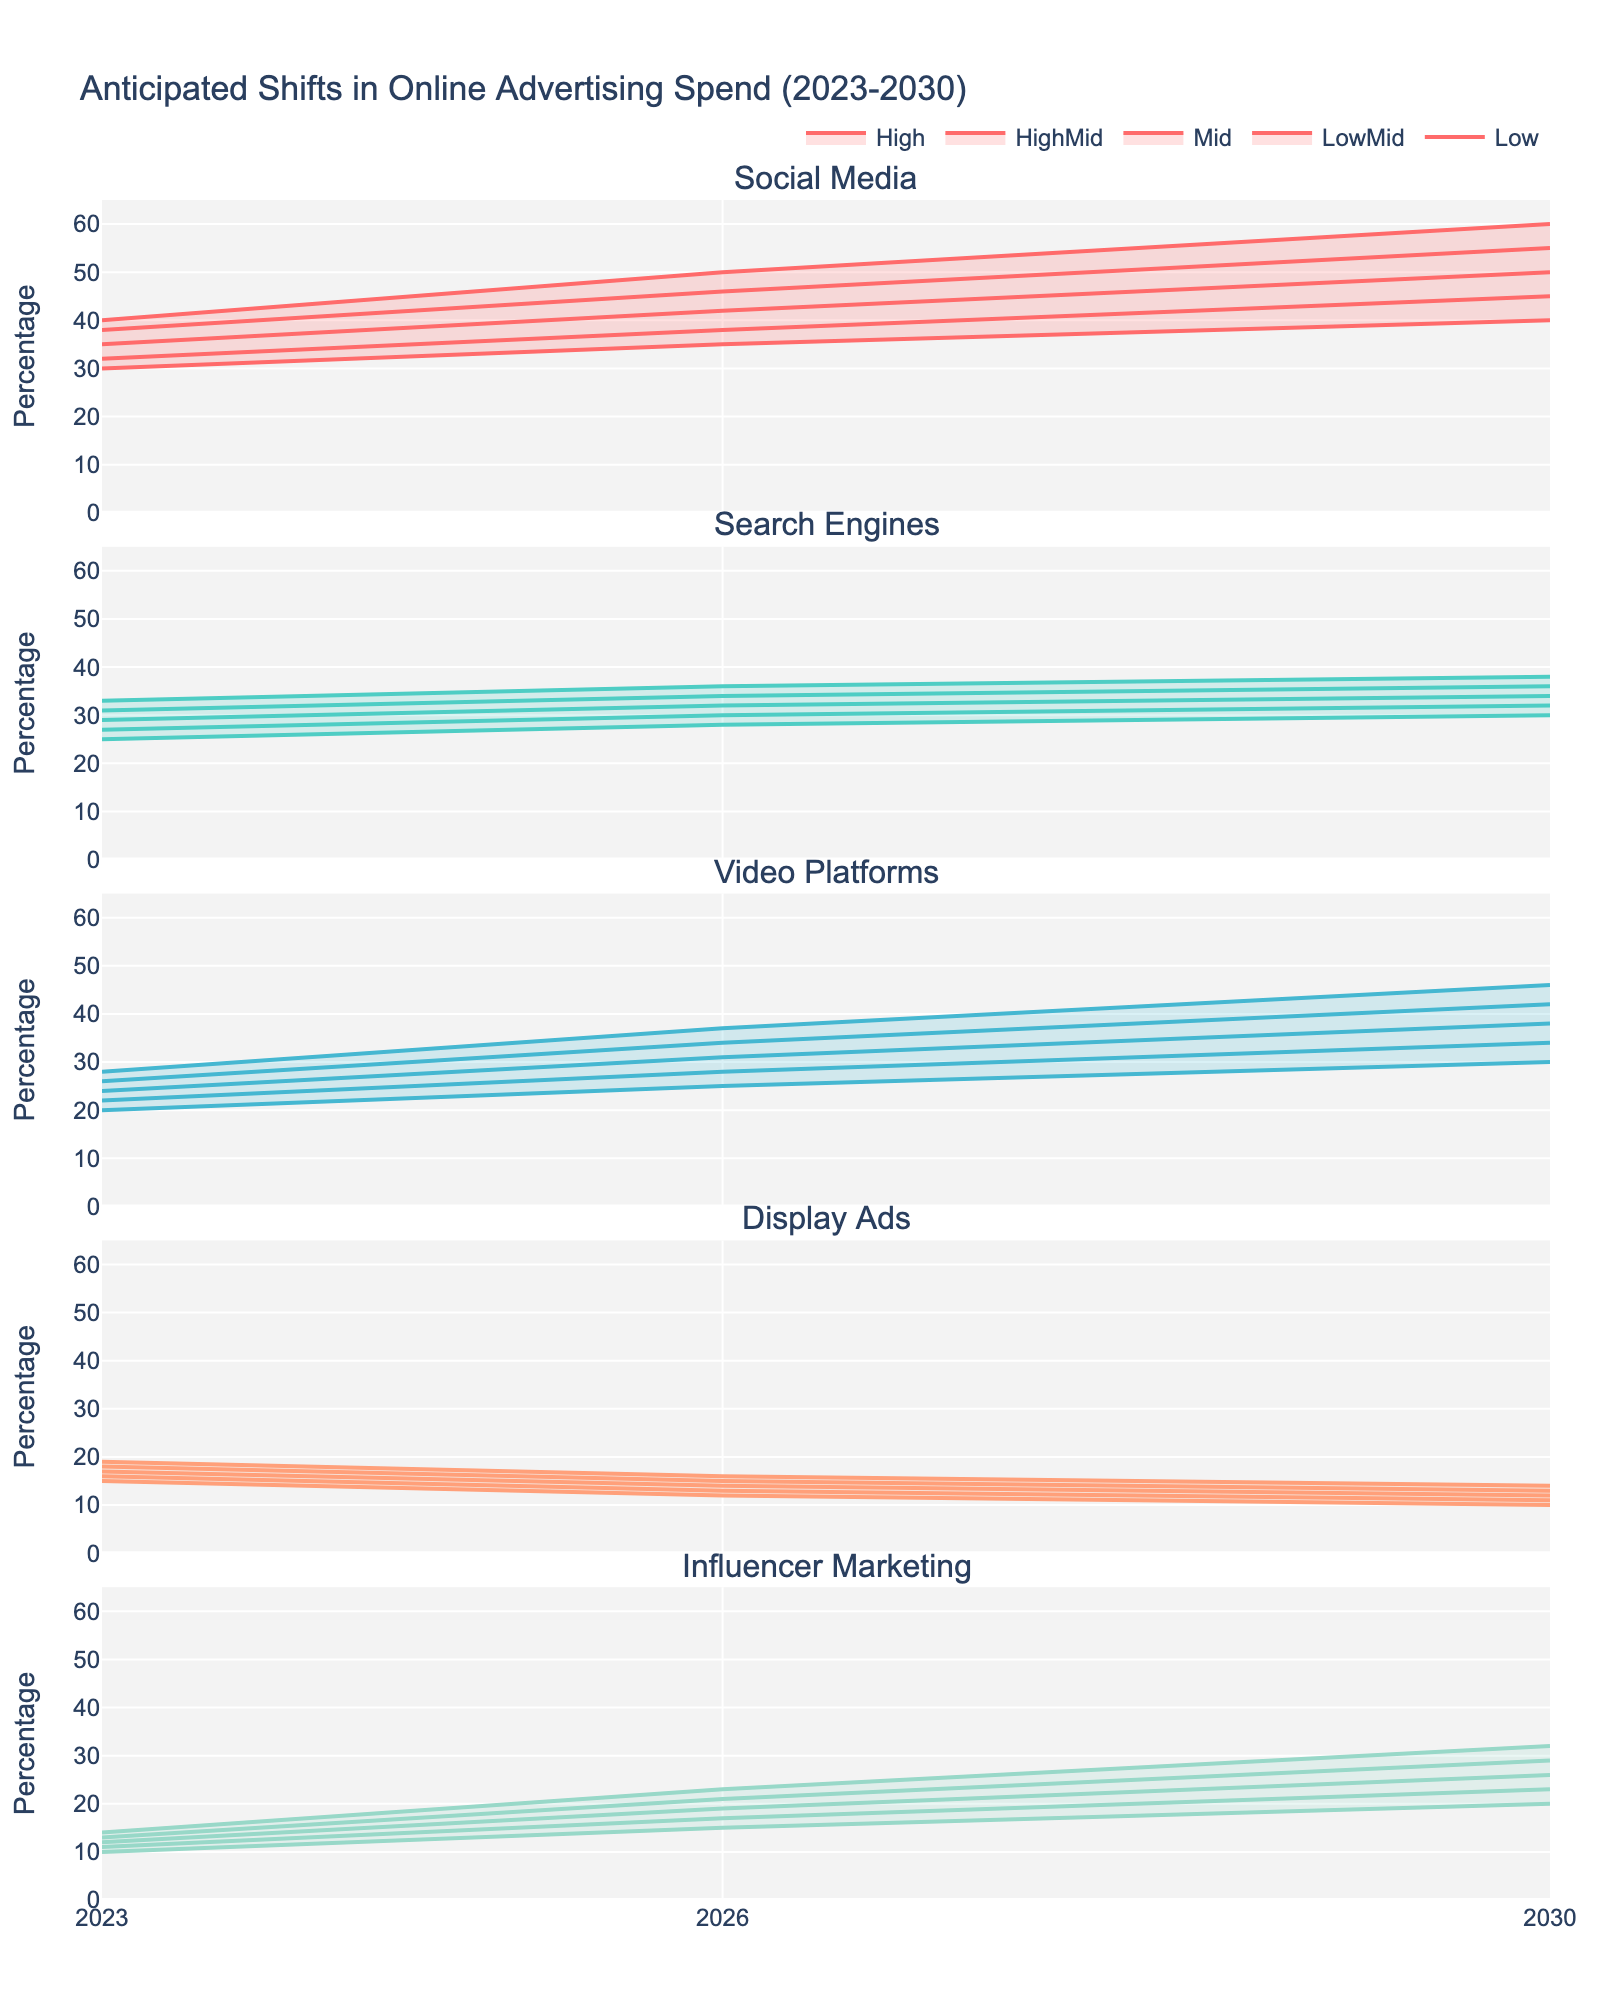What is the title of the figure? The title is usually located at the top of the figure. By reading it, we understand that it describes changes in online advertising spending over specific years.
Answer: Anticipated Shifts in Online Advertising Spend (2023-2030) How many distinct channels of online advertising are shown in the figure? The subplot titles, which are displayed above each subplot, represent the different channels. By counting these titles, we can determine the number of channels.
Answer: Five Which channel is projected to have the highest increase in spending by 2030 under the "High" scenario? Looking at the "High" scenario, i.e., the highest line in each subplot for the year 2030, the one with the highest value represents the highest increase.
Answer: Social Media What are the mid-range values for Influencer Marketing in the years 2023, 2026, and 2030? Locate the mid-point in the range for Influencer Marketing each year by identifying the values marked as "Mid". These values are indicated along the y-axis where the "Mid" line intersects with the year on the x-axis.
Answer: 12, 19, 26 Which advertising channel shows a decline in the "Low" scenario from 2023 to 2030? Observe the "Low" scenario lines, which are the lowest lines in each subplot. Find any line that shows a decrease from 2023 to 2030.
Answer: Display Ads What is the trend in advertising spend for Video Platforms from 2023 to 2030 under the "Mid" scenario? Follow the "Mid" scenario line for Video Platforms from 2023 to 2030. Look for increases or decreases in this line.
Answer: Increasing On average, how much is the anticipated spend on Social Media and Search Engines in 2026 under the "HighMid" scenario? Find the "HighMid" values for Social Media and Search Engines in 2026, sum them, and then divide by 2 to get the average. (46 + 34) / 2
Answer: 40 Which year shows the lowest projected spend for Display Ads under the "LowMid" scenario? Compare the "LowMid" scenario values for Display Ads across the different years. The smallest value represents the lowest projected spend.
Answer: 2030 If you combine the high-end projections for Video Platforms in 2023 and Display Ads in 2030, what is the total percentage? Locate the high-end projections ("High") for both categories in their respective years and sum them up. 28 + 14
Answer: 42 